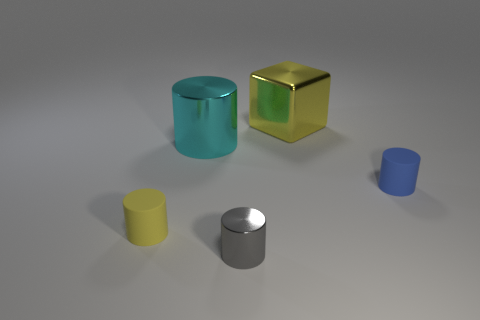There is a tiny matte cylinder left of the blue cylinder; does it have the same color as the big object behind the cyan metallic thing?
Provide a succinct answer. Yes. Is the number of things behind the gray thing greater than the number of blocks that are in front of the large cyan metallic cylinder?
Ensure brevity in your answer.  Yes. Do the matte cylinder on the right side of the metal cube and the big cyan metal object have the same size?
Your answer should be compact. No. What number of rubber cylinders are in front of the matte cylinder that is on the left side of the large object that is right of the tiny metallic thing?
Your answer should be compact. 0. There is a thing that is both on the left side of the big yellow shiny object and on the right side of the cyan shiny object; what size is it?
Provide a succinct answer. Small. How many other objects are the same shape as the cyan thing?
Ensure brevity in your answer.  3. There is a cyan metallic thing; what number of tiny yellow objects are to the right of it?
Offer a terse response. 0. Is the number of shiny cylinders that are on the left side of the large cylinder less than the number of small cylinders that are on the right side of the yellow metal cube?
Keep it short and to the point. Yes. The yellow thing that is behind the rubber thing behind the yellow thing that is to the left of the big yellow cube is what shape?
Offer a very short reply. Cube. What shape is the shiny object that is both behind the yellow rubber thing and on the right side of the cyan shiny object?
Offer a terse response. Cube. 